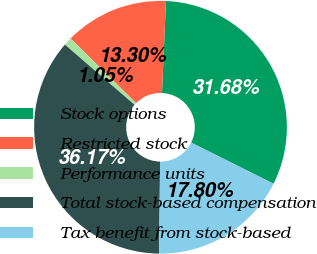Convert chart to OTSL. <chart><loc_0><loc_0><loc_500><loc_500><pie_chart><fcel>Stock options<fcel>Restricted stock<fcel>Performance units<fcel>Total stock-based compensation<fcel>Tax benefit from stock-based<nl><fcel>31.68%<fcel>13.3%<fcel>1.05%<fcel>36.17%<fcel>17.8%<nl></chart> 